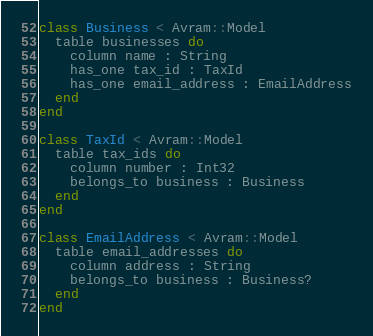<code> <loc_0><loc_0><loc_500><loc_500><_Crystal_>class Business < Avram::Model
  table businesses do
    column name : String
    has_one tax_id : TaxId
    has_one email_address : EmailAddress
  end
end

class TaxId < Avram::Model
  table tax_ids do
    column number : Int32
    belongs_to business : Business
  end
end

class EmailAddress < Avram::Model
  table email_addresses do
    column address : String
    belongs_to business : Business?
  end
end
</code> 